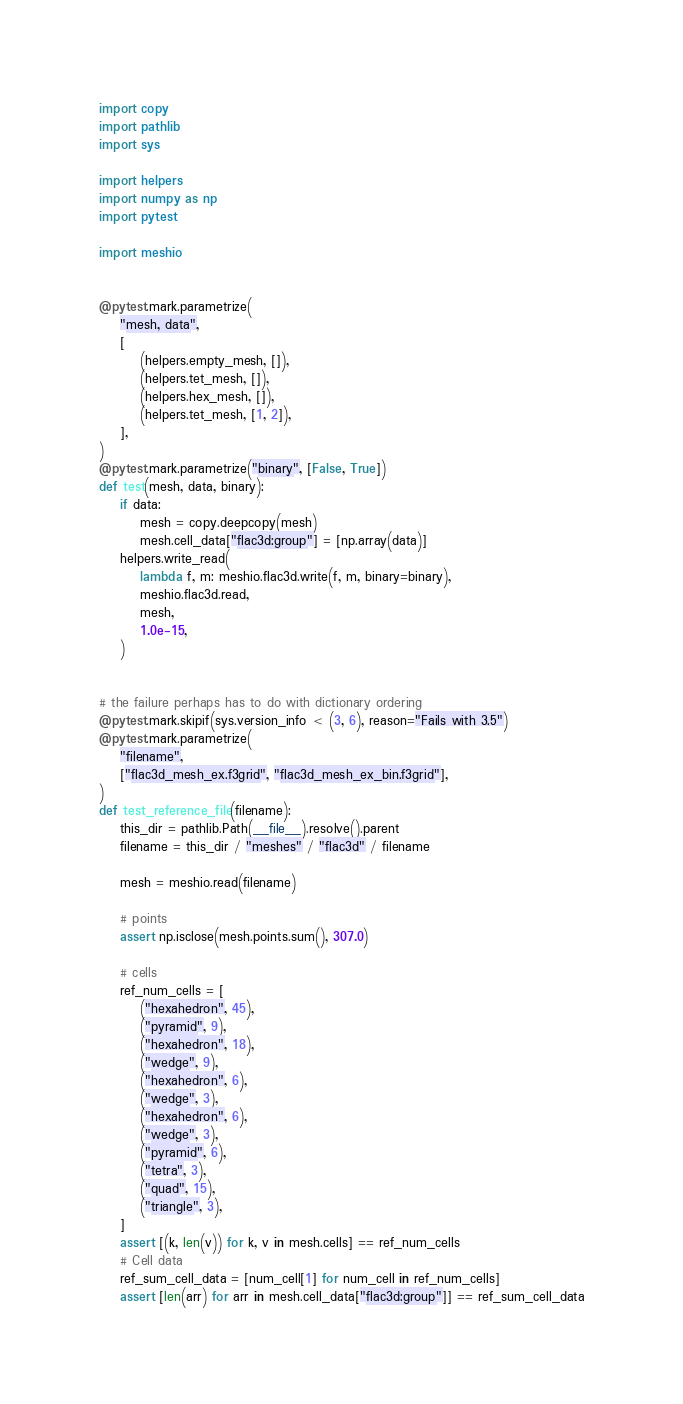<code> <loc_0><loc_0><loc_500><loc_500><_Python_>import copy
import pathlib
import sys

import helpers
import numpy as np
import pytest

import meshio


@pytest.mark.parametrize(
    "mesh, data",
    [
        (helpers.empty_mesh, []),
        (helpers.tet_mesh, []),
        (helpers.hex_mesh, []),
        (helpers.tet_mesh, [1, 2]),
    ],
)
@pytest.mark.parametrize("binary", [False, True])
def test(mesh, data, binary):
    if data:
        mesh = copy.deepcopy(mesh)
        mesh.cell_data["flac3d:group"] = [np.array(data)]
    helpers.write_read(
        lambda f, m: meshio.flac3d.write(f, m, binary=binary),
        meshio.flac3d.read,
        mesh,
        1.0e-15,
    )


# the failure perhaps has to do with dictionary ordering
@pytest.mark.skipif(sys.version_info < (3, 6), reason="Fails with 3.5")
@pytest.mark.parametrize(
    "filename",
    ["flac3d_mesh_ex.f3grid", "flac3d_mesh_ex_bin.f3grid"],
)
def test_reference_file(filename):
    this_dir = pathlib.Path(__file__).resolve().parent
    filename = this_dir / "meshes" / "flac3d" / filename

    mesh = meshio.read(filename)

    # points
    assert np.isclose(mesh.points.sum(), 307.0)

    # cells
    ref_num_cells = [
        ("hexahedron", 45),
        ("pyramid", 9),
        ("hexahedron", 18),
        ("wedge", 9),
        ("hexahedron", 6),
        ("wedge", 3),
        ("hexahedron", 6),
        ("wedge", 3),
        ("pyramid", 6),
        ("tetra", 3),
        ("quad", 15),
        ("triangle", 3),
    ]
    assert [(k, len(v)) for k, v in mesh.cells] == ref_num_cells
    # Cell data
    ref_sum_cell_data = [num_cell[1] for num_cell in ref_num_cells]
    assert [len(arr) for arr in mesh.cell_data["flac3d:group"]] == ref_sum_cell_data
</code> 